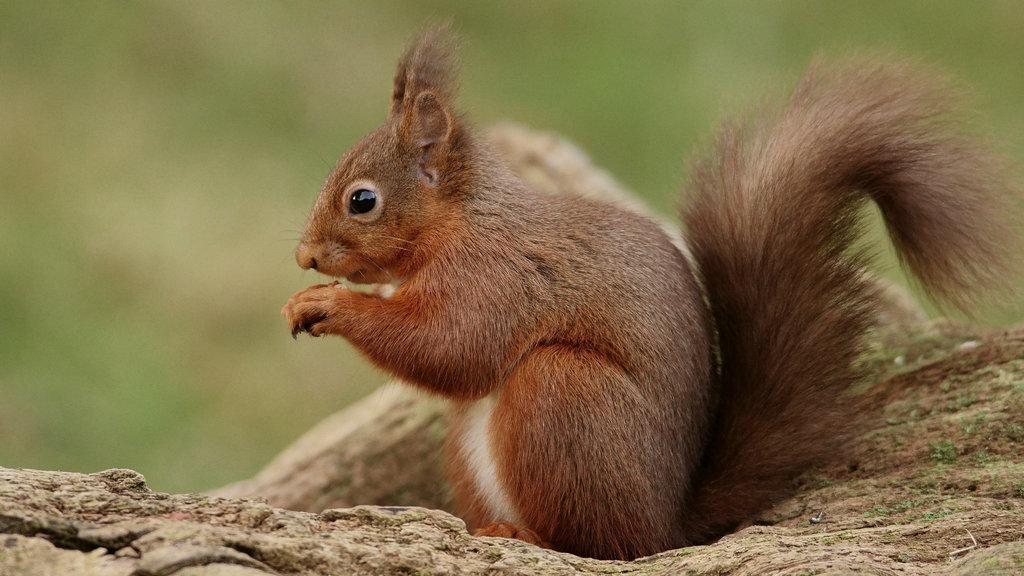Could you give a brief overview of what you see in this image? This image is taken outdoors. In this image the background is a little blurred and it is green in color. At the bottom of the image there is a ground with grass on it. In the middle of the image there is a squirrel. 